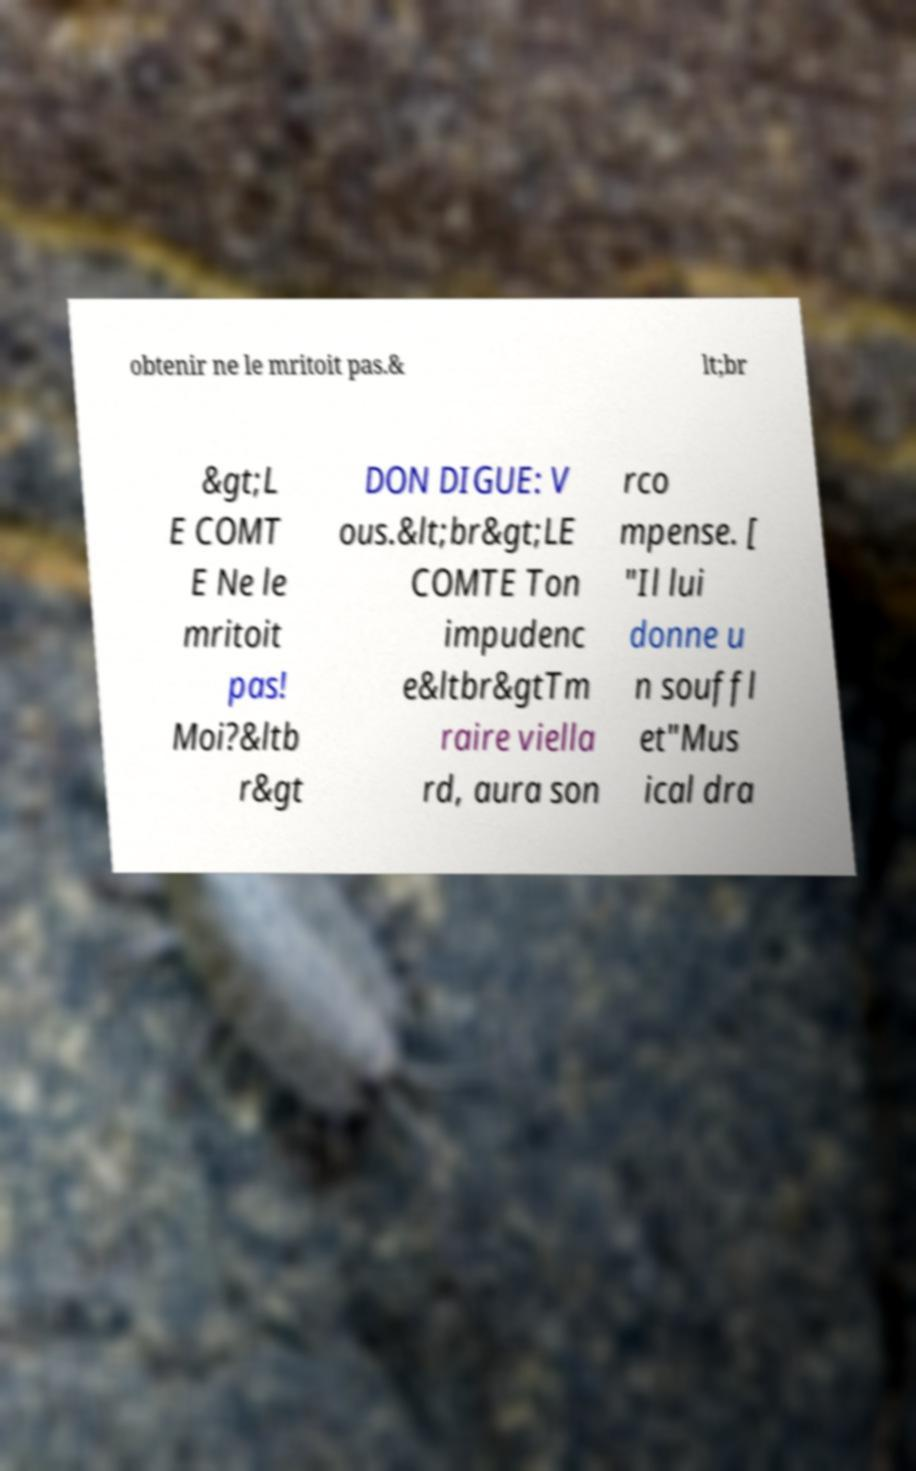Please identify and transcribe the text found in this image. obtenir ne le mritoit pas.& lt;br &gt;L E COMT E Ne le mritoit pas! Moi?&ltb r&gt DON DIGUE: V ous.&lt;br&gt;LE COMTE Ton impudenc e&ltbr&gtTm raire viella rd, aura son rco mpense. [ "Il lui donne u n souffl et"Mus ical dra 